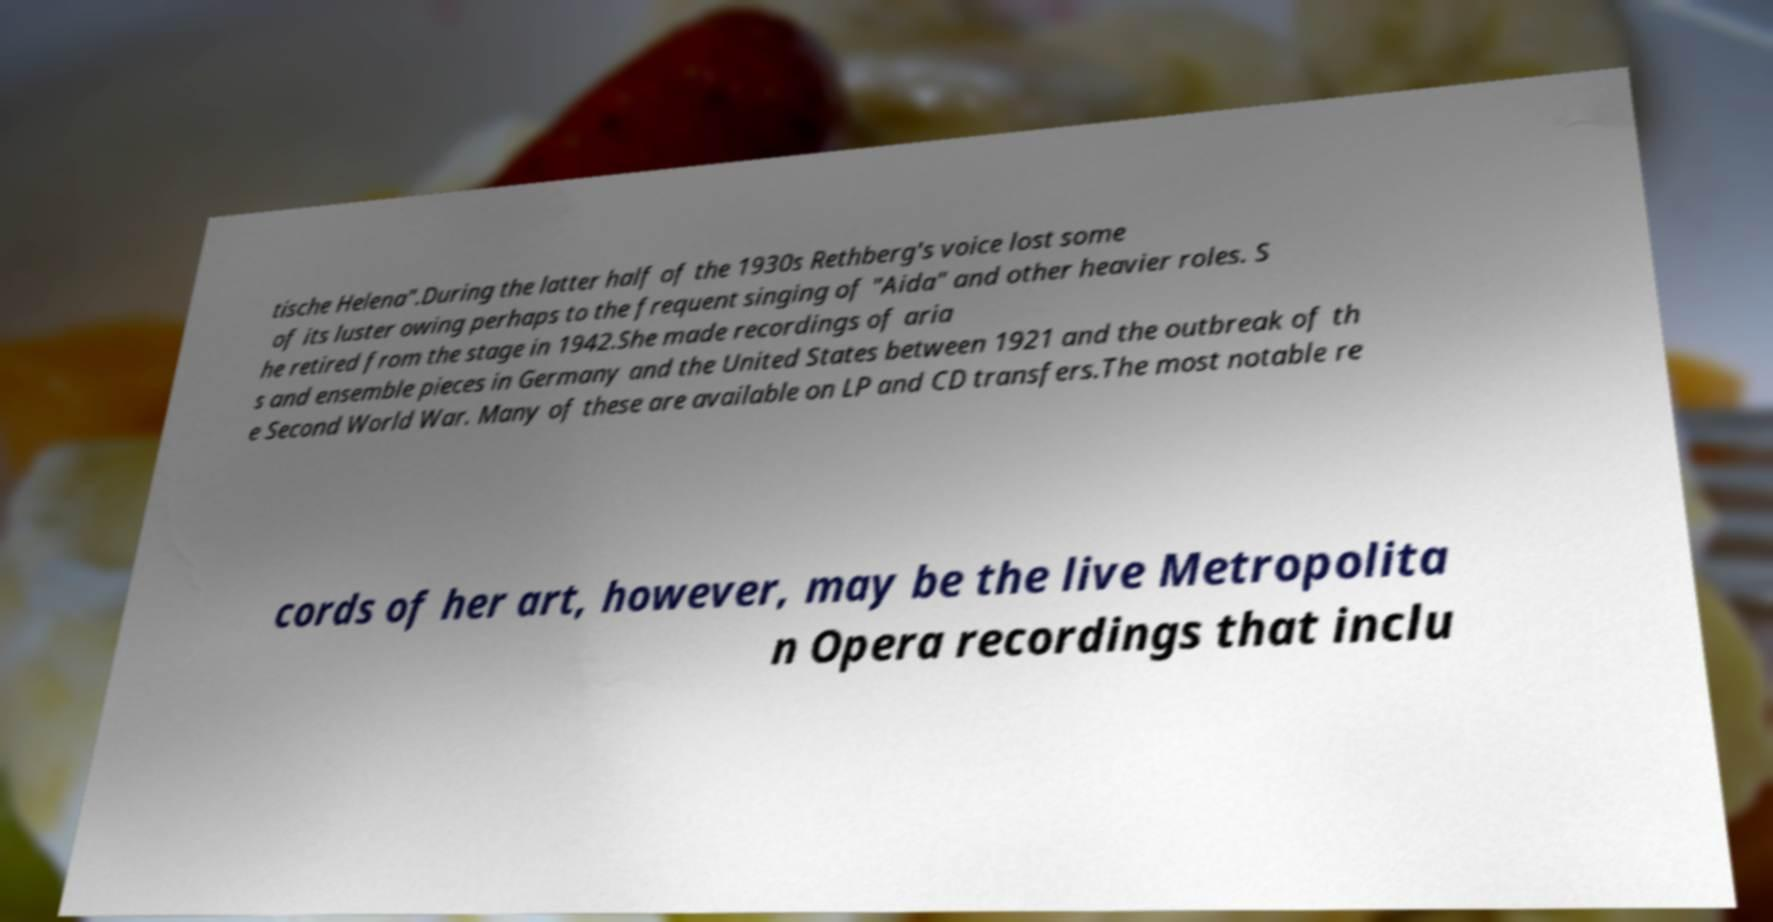There's text embedded in this image that I need extracted. Can you transcribe it verbatim? tische Helena".During the latter half of the 1930s Rethberg's voice lost some of its luster owing perhaps to the frequent singing of "Aida" and other heavier roles. S he retired from the stage in 1942.She made recordings of aria s and ensemble pieces in Germany and the United States between 1921 and the outbreak of th e Second World War. Many of these are available on LP and CD transfers.The most notable re cords of her art, however, may be the live Metropolita n Opera recordings that inclu 